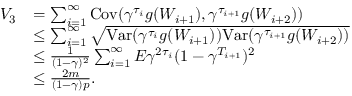Convert formula to latex. <formula><loc_0><loc_0><loc_500><loc_500>\begin{array} { r l } { V _ { 3 } } & { = \sum _ { i = 1 } ^ { \infty } C o v ( \gamma ^ { \tau _ { i } } g ( W _ { i + 1 } ) , \gamma ^ { \tau _ { i + 1 } } g ( W _ { i + 2 } ) ) } \\ & { \leq \sum _ { i = 1 } ^ { \infty } \sqrt { V a r ( \gamma ^ { \tau _ { i } } g ( W _ { i + 1 } ) ) V a r ( \gamma ^ { \tau _ { i + 1 } } g ( W _ { i + 2 } ) ) } } \\ & { \leq \frac { 1 } { ( 1 - \gamma ) ^ { 2 } } \sum _ { i = 1 } ^ { \infty } E \gamma ^ { 2 \tau _ { i } } ( 1 - \gamma ^ { T _ { i + 1 } } ) ^ { 2 } } \\ & { \leq \frac { 2 m } { ( 1 - \gamma ) p } . } \end{array}</formula> 